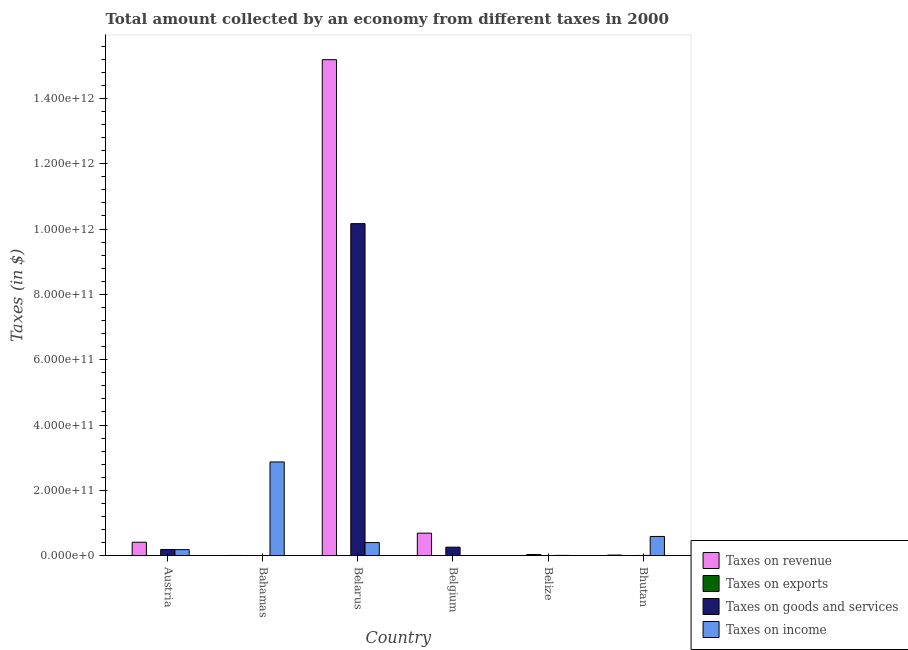Are the number of bars per tick equal to the number of legend labels?
Offer a very short reply. Yes. How many bars are there on the 5th tick from the right?
Your answer should be very brief. 4. What is the label of the 1st group of bars from the left?
Make the answer very short. Austria. In how many cases, is the number of bars for a given country not equal to the number of legend labels?
Your answer should be compact. 0. What is the amount collected as tax on revenue in Belarus?
Give a very brief answer. 1.52e+12. Across all countries, what is the maximum amount collected as tax on income?
Your answer should be compact. 2.87e+11. Across all countries, what is the minimum amount collected as tax on goods?
Offer a very short reply. 6.13e+07. In which country was the amount collected as tax on exports maximum?
Your answer should be very brief. Belize. What is the total amount collected as tax on exports in the graph?
Your answer should be very brief. 3.93e+09. What is the difference between the amount collected as tax on income in Bahamas and that in Belarus?
Provide a short and direct response. 2.47e+11. What is the difference between the amount collected as tax on goods in Bhutan and the amount collected as tax on income in Austria?
Offer a very short reply. -1.78e+1. What is the average amount collected as tax on revenue per country?
Ensure brevity in your answer.  2.72e+11. What is the difference between the amount collected as tax on exports and amount collected as tax on income in Austria?
Provide a succinct answer. -1.87e+1. What is the ratio of the amount collected as tax on income in Bahamas to that in Belgium?
Your answer should be very brief. 3760.61. What is the difference between the highest and the second highest amount collected as tax on exports?
Provide a succinct answer. 3.56e+09. What is the difference between the highest and the lowest amount collected as tax on income?
Provide a short and direct response. 2.87e+11. In how many countries, is the amount collected as tax on revenue greater than the average amount collected as tax on revenue taken over all countries?
Provide a short and direct response. 1. What does the 2nd bar from the left in Belarus represents?
Keep it short and to the point. Taxes on exports. What does the 3rd bar from the right in Belize represents?
Provide a succinct answer. Taxes on exports. How many bars are there?
Give a very brief answer. 24. Are all the bars in the graph horizontal?
Provide a succinct answer. No. How many countries are there in the graph?
Keep it short and to the point. 6. What is the difference between two consecutive major ticks on the Y-axis?
Your response must be concise. 2.00e+11. Are the values on the major ticks of Y-axis written in scientific E-notation?
Offer a terse response. Yes. Does the graph contain any zero values?
Your answer should be very brief. No. Does the graph contain grids?
Your answer should be compact. No. How many legend labels are there?
Make the answer very short. 4. What is the title of the graph?
Give a very brief answer. Total amount collected by an economy from different taxes in 2000. Does "Secondary schools" appear as one of the legend labels in the graph?
Keep it short and to the point. No. What is the label or title of the Y-axis?
Make the answer very short. Taxes (in $). What is the Taxes (in $) in Taxes on revenue in Austria?
Give a very brief answer. 4.13e+1. What is the Taxes (in $) in Taxes on exports in Austria?
Keep it short and to the point. 9.91e+04. What is the Taxes (in $) in Taxes on goods and services in Austria?
Offer a terse response. 1.91e+1. What is the Taxes (in $) of Taxes on income in Austria?
Offer a terse response. 1.87e+1. What is the Taxes (in $) in Taxes on revenue in Bahamas?
Keep it short and to the point. 8.62e+08. What is the Taxes (in $) in Taxes on exports in Bahamas?
Give a very brief answer. 1.15e+08. What is the Taxes (in $) of Taxes on goods and services in Bahamas?
Provide a succinct answer. 6.13e+07. What is the Taxes (in $) of Taxes on income in Bahamas?
Make the answer very short. 2.87e+11. What is the Taxes (in $) in Taxes on revenue in Belarus?
Offer a terse response. 1.52e+12. What is the Taxes (in $) of Taxes on exports in Belarus?
Keep it short and to the point. 1.49e+06. What is the Taxes (in $) in Taxes on goods and services in Belarus?
Give a very brief answer. 1.02e+12. What is the Taxes (in $) in Taxes on income in Belarus?
Your answer should be compact. 4.02e+1. What is the Taxes (in $) of Taxes on revenue in Belgium?
Offer a very short reply. 6.90e+1. What is the Taxes (in $) in Taxes on exports in Belgium?
Keep it short and to the point. 1.20e+07. What is the Taxes (in $) in Taxes on goods and services in Belgium?
Your answer should be very brief. 2.61e+1. What is the Taxes (in $) of Taxes on income in Belgium?
Offer a terse response. 7.63e+07. What is the Taxes (in $) of Taxes on revenue in Belize?
Your answer should be very brief. 2.97e+08. What is the Taxes (in $) of Taxes on exports in Belize?
Provide a succinct answer. 3.68e+09. What is the Taxes (in $) in Taxes on goods and services in Belize?
Offer a very short reply. 1.02e+08. What is the Taxes (in $) of Taxes on income in Belize?
Make the answer very short. 1.06e+09. What is the Taxes (in $) in Taxes on revenue in Bhutan?
Give a very brief answer. 1.98e+09. What is the Taxes (in $) in Taxes on exports in Bhutan?
Make the answer very short. 1.21e+08. What is the Taxes (in $) of Taxes on goods and services in Bhutan?
Give a very brief answer. 8.42e+08. What is the Taxes (in $) in Taxes on income in Bhutan?
Offer a very short reply. 5.90e+1. Across all countries, what is the maximum Taxes (in $) of Taxes on revenue?
Make the answer very short. 1.52e+12. Across all countries, what is the maximum Taxes (in $) in Taxes on exports?
Offer a very short reply. 3.68e+09. Across all countries, what is the maximum Taxes (in $) of Taxes on goods and services?
Keep it short and to the point. 1.02e+12. Across all countries, what is the maximum Taxes (in $) of Taxes on income?
Ensure brevity in your answer.  2.87e+11. Across all countries, what is the minimum Taxes (in $) of Taxes on revenue?
Keep it short and to the point. 2.97e+08. Across all countries, what is the minimum Taxes (in $) of Taxes on exports?
Offer a very short reply. 9.91e+04. Across all countries, what is the minimum Taxes (in $) of Taxes on goods and services?
Your answer should be compact. 6.13e+07. Across all countries, what is the minimum Taxes (in $) of Taxes on income?
Offer a terse response. 7.63e+07. What is the total Taxes (in $) of Taxes on revenue in the graph?
Give a very brief answer. 1.63e+12. What is the total Taxes (in $) in Taxes on exports in the graph?
Your answer should be very brief. 3.93e+09. What is the total Taxes (in $) of Taxes on goods and services in the graph?
Offer a very short reply. 1.06e+12. What is the total Taxes (in $) in Taxes on income in the graph?
Your response must be concise. 4.06e+11. What is the difference between the Taxes (in $) in Taxes on revenue in Austria and that in Bahamas?
Offer a very short reply. 4.04e+1. What is the difference between the Taxes (in $) of Taxes on exports in Austria and that in Bahamas?
Make the answer very short. -1.15e+08. What is the difference between the Taxes (in $) of Taxes on goods and services in Austria and that in Bahamas?
Your answer should be very brief. 1.90e+1. What is the difference between the Taxes (in $) in Taxes on income in Austria and that in Bahamas?
Give a very brief answer. -2.68e+11. What is the difference between the Taxes (in $) of Taxes on revenue in Austria and that in Belarus?
Ensure brevity in your answer.  -1.48e+12. What is the difference between the Taxes (in $) in Taxes on exports in Austria and that in Belarus?
Your response must be concise. -1.39e+06. What is the difference between the Taxes (in $) of Taxes on goods and services in Austria and that in Belarus?
Your response must be concise. -9.97e+11. What is the difference between the Taxes (in $) of Taxes on income in Austria and that in Belarus?
Provide a succinct answer. -2.15e+1. What is the difference between the Taxes (in $) of Taxes on revenue in Austria and that in Belgium?
Provide a succinct answer. -2.78e+1. What is the difference between the Taxes (in $) of Taxes on exports in Austria and that in Belgium?
Give a very brief answer. -1.19e+07. What is the difference between the Taxes (in $) of Taxes on goods and services in Austria and that in Belgium?
Ensure brevity in your answer.  -7.08e+09. What is the difference between the Taxes (in $) of Taxes on income in Austria and that in Belgium?
Offer a terse response. 1.86e+1. What is the difference between the Taxes (in $) of Taxes on revenue in Austria and that in Belize?
Ensure brevity in your answer.  4.10e+1. What is the difference between the Taxes (in $) of Taxes on exports in Austria and that in Belize?
Your response must be concise. -3.68e+09. What is the difference between the Taxes (in $) of Taxes on goods and services in Austria and that in Belize?
Offer a terse response. 1.90e+1. What is the difference between the Taxes (in $) in Taxes on income in Austria and that in Belize?
Your answer should be very brief. 1.76e+1. What is the difference between the Taxes (in $) of Taxes on revenue in Austria and that in Bhutan?
Give a very brief answer. 3.93e+1. What is the difference between the Taxes (in $) of Taxes on exports in Austria and that in Bhutan?
Make the answer very short. -1.21e+08. What is the difference between the Taxes (in $) in Taxes on goods and services in Austria and that in Bhutan?
Your answer should be compact. 1.82e+1. What is the difference between the Taxes (in $) of Taxes on income in Austria and that in Bhutan?
Ensure brevity in your answer.  -4.03e+1. What is the difference between the Taxes (in $) in Taxes on revenue in Bahamas and that in Belarus?
Your answer should be very brief. -1.52e+12. What is the difference between the Taxes (in $) in Taxes on exports in Bahamas and that in Belarus?
Your answer should be compact. 1.13e+08. What is the difference between the Taxes (in $) in Taxes on goods and services in Bahamas and that in Belarus?
Your response must be concise. -1.02e+12. What is the difference between the Taxes (in $) in Taxes on income in Bahamas and that in Belarus?
Provide a succinct answer. 2.47e+11. What is the difference between the Taxes (in $) in Taxes on revenue in Bahamas and that in Belgium?
Your answer should be compact. -6.82e+1. What is the difference between the Taxes (in $) in Taxes on exports in Bahamas and that in Belgium?
Provide a succinct answer. 1.03e+08. What is the difference between the Taxes (in $) in Taxes on goods and services in Bahamas and that in Belgium?
Keep it short and to the point. -2.61e+1. What is the difference between the Taxes (in $) of Taxes on income in Bahamas and that in Belgium?
Provide a short and direct response. 2.87e+11. What is the difference between the Taxes (in $) of Taxes on revenue in Bahamas and that in Belize?
Your answer should be compact. 5.66e+08. What is the difference between the Taxes (in $) in Taxes on exports in Bahamas and that in Belize?
Make the answer very short. -3.57e+09. What is the difference between the Taxes (in $) in Taxes on goods and services in Bahamas and that in Belize?
Offer a terse response. -4.05e+07. What is the difference between the Taxes (in $) in Taxes on income in Bahamas and that in Belize?
Provide a succinct answer. 2.86e+11. What is the difference between the Taxes (in $) of Taxes on revenue in Bahamas and that in Bhutan?
Give a very brief answer. -1.11e+09. What is the difference between the Taxes (in $) of Taxes on exports in Bahamas and that in Bhutan?
Offer a very short reply. -5.84e+06. What is the difference between the Taxes (in $) of Taxes on goods and services in Bahamas and that in Bhutan?
Ensure brevity in your answer.  -7.81e+08. What is the difference between the Taxes (in $) in Taxes on income in Bahamas and that in Bhutan?
Provide a succinct answer. 2.28e+11. What is the difference between the Taxes (in $) in Taxes on revenue in Belarus and that in Belgium?
Offer a terse response. 1.45e+12. What is the difference between the Taxes (in $) of Taxes on exports in Belarus and that in Belgium?
Offer a very short reply. -1.05e+07. What is the difference between the Taxes (in $) of Taxes on goods and services in Belarus and that in Belgium?
Ensure brevity in your answer.  9.90e+11. What is the difference between the Taxes (in $) of Taxes on income in Belarus and that in Belgium?
Ensure brevity in your answer.  4.01e+1. What is the difference between the Taxes (in $) of Taxes on revenue in Belarus and that in Belize?
Your answer should be very brief. 1.52e+12. What is the difference between the Taxes (in $) of Taxes on exports in Belarus and that in Belize?
Your answer should be compact. -3.68e+09. What is the difference between the Taxes (in $) of Taxes on goods and services in Belarus and that in Belize?
Keep it short and to the point. 1.02e+12. What is the difference between the Taxes (in $) in Taxes on income in Belarus and that in Belize?
Provide a succinct answer. 3.91e+1. What is the difference between the Taxes (in $) in Taxes on revenue in Belarus and that in Bhutan?
Ensure brevity in your answer.  1.52e+12. What is the difference between the Taxes (in $) of Taxes on exports in Belarus and that in Bhutan?
Your response must be concise. -1.19e+08. What is the difference between the Taxes (in $) of Taxes on goods and services in Belarus and that in Bhutan?
Keep it short and to the point. 1.02e+12. What is the difference between the Taxes (in $) in Taxes on income in Belarus and that in Bhutan?
Offer a terse response. -1.88e+1. What is the difference between the Taxes (in $) in Taxes on revenue in Belgium and that in Belize?
Provide a succinct answer. 6.87e+1. What is the difference between the Taxes (in $) of Taxes on exports in Belgium and that in Belize?
Your answer should be compact. -3.67e+09. What is the difference between the Taxes (in $) in Taxes on goods and services in Belgium and that in Belize?
Your answer should be compact. 2.60e+1. What is the difference between the Taxes (in $) in Taxes on income in Belgium and that in Belize?
Your answer should be compact. -9.80e+08. What is the difference between the Taxes (in $) in Taxes on revenue in Belgium and that in Bhutan?
Your response must be concise. 6.70e+1. What is the difference between the Taxes (in $) in Taxes on exports in Belgium and that in Bhutan?
Your answer should be compact. -1.09e+08. What is the difference between the Taxes (in $) of Taxes on goods and services in Belgium and that in Bhutan?
Ensure brevity in your answer.  2.53e+1. What is the difference between the Taxes (in $) of Taxes on income in Belgium and that in Bhutan?
Your answer should be compact. -5.89e+1. What is the difference between the Taxes (in $) of Taxes on revenue in Belize and that in Bhutan?
Provide a succinct answer. -1.68e+09. What is the difference between the Taxes (in $) of Taxes on exports in Belize and that in Bhutan?
Offer a very short reply. 3.56e+09. What is the difference between the Taxes (in $) of Taxes on goods and services in Belize and that in Bhutan?
Your answer should be compact. -7.41e+08. What is the difference between the Taxes (in $) of Taxes on income in Belize and that in Bhutan?
Make the answer very short. -5.79e+1. What is the difference between the Taxes (in $) of Taxes on revenue in Austria and the Taxes (in $) of Taxes on exports in Bahamas?
Your response must be concise. 4.11e+1. What is the difference between the Taxes (in $) of Taxes on revenue in Austria and the Taxes (in $) of Taxes on goods and services in Bahamas?
Provide a succinct answer. 4.12e+1. What is the difference between the Taxes (in $) of Taxes on revenue in Austria and the Taxes (in $) of Taxes on income in Bahamas?
Give a very brief answer. -2.46e+11. What is the difference between the Taxes (in $) in Taxes on exports in Austria and the Taxes (in $) in Taxes on goods and services in Bahamas?
Keep it short and to the point. -6.12e+07. What is the difference between the Taxes (in $) of Taxes on exports in Austria and the Taxes (in $) of Taxes on income in Bahamas?
Your answer should be compact. -2.87e+11. What is the difference between the Taxes (in $) in Taxes on goods and services in Austria and the Taxes (in $) in Taxes on income in Bahamas?
Your answer should be compact. -2.68e+11. What is the difference between the Taxes (in $) in Taxes on revenue in Austria and the Taxes (in $) in Taxes on exports in Belarus?
Keep it short and to the point. 4.13e+1. What is the difference between the Taxes (in $) in Taxes on revenue in Austria and the Taxes (in $) in Taxes on goods and services in Belarus?
Keep it short and to the point. -9.75e+11. What is the difference between the Taxes (in $) in Taxes on revenue in Austria and the Taxes (in $) in Taxes on income in Belarus?
Offer a very short reply. 1.07e+09. What is the difference between the Taxes (in $) of Taxes on exports in Austria and the Taxes (in $) of Taxes on goods and services in Belarus?
Provide a succinct answer. -1.02e+12. What is the difference between the Taxes (in $) of Taxes on exports in Austria and the Taxes (in $) of Taxes on income in Belarus?
Make the answer very short. -4.02e+1. What is the difference between the Taxes (in $) in Taxes on goods and services in Austria and the Taxes (in $) in Taxes on income in Belarus?
Your response must be concise. -2.11e+1. What is the difference between the Taxes (in $) of Taxes on revenue in Austria and the Taxes (in $) of Taxes on exports in Belgium?
Ensure brevity in your answer.  4.12e+1. What is the difference between the Taxes (in $) in Taxes on revenue in Austria and the Taxes (in $) in Taxes on goods and services in Belgium?
Keep it short and to the point. 1.51e+1. What is the difference between the Taxes (in $) in Taxes on revenue in Austria and the Taxes (in $) in Taxes on income in Belgium?
Keep it short and to the point. 4.12e+1. What is the difference between the Taxes (in $) of Taxes on exports in Austria and the Taxes (in $) of Taxes on goods and services in Belgium?
Your response must be concise. -2.61e+1. What is the difference between the Taxes (in $) of Taxes on exports in Austria and the Taxes (in $) of Taxes on income in Belgium?
Keep it short and to the point. -7.62e+07. What is the difference between the Taxes (in $) of Taxes on goods and services in Austria and the Taxes (in $) of Taxes on income in Belgium?
Your response must be concise. 1.90e+1. What is the difference between the Taxes (in $) of Taxes on revenue in Austria and the Taxes (in $) of Taxes on exports in Belize?
Offer a terse response. 3.76e+1. What is the difference between the Taxes (in $) of Taxes on revenue in Austria and the Taxes (in $) of Taxes on goods and services in Belize?
Keep it short and to the point. 4.12e+1. What is the difference between the Taxes (in $) in Taxes on revenue in Austria and the Taxes (in $) in Taxes on income in Belize?
Make the answer very short. 4.02e+1. What is the difference between the Taxes (in $) in Taxes on exports in Austria and the Taxes (in $) in Taxes on goods and services in Belize?
Make the answer very short. -1.02e+08. What is the difference between the Taxes (in $) in Taxes on exports in Austria and the Taxes (in $) in Taxes on income in Belize?
Provide a short and direct response. -1.06e+09. What is the difference between the Taxes (in $) in Taxes on goods and services in Austria and the Taxes (in $) in Taxes on income in Belize?
Ensure brevity in your answer.  1.80e+1. What is the difference between the Taxes (in $) of Taxes on revenue in Austria and the Taxes (in $) of Taxes on exports in Bhutan?
Your answer should be compact. 4.11e+1. What is the difference between the Taxes (in $) in Taxes on revenue in Austria and the Taxes (in $) in Taxes on goods and services in Bhutan?
Keep it short and to the point. 4.04e+1. What is the difference between the Taxes (in $) of Taxes on revenue in Austria and the Taxes (in $) of Taxes on income in Bhutan?
Your answer should be compact. -1.77e+1. What is the difference between the Taxes (in $) in Taxes on exports in Austria and the Taxes (in $) in Taxes on goods and services in Bhutan?
Make the answer very short. -8.42e+08. What is the difference between the Taxes (in $) of Taxes on exports in Austria and the Taxes (in $) of Taxes on income in Bhutan?
Offer a very short reply. -5.90e+1. What is the difference between the Taxes (in $) of Taxes on goods and services in Austria and the Taxes (in $) of Taxes on income in Bhutan?
Offer a very short reply. -3.99e+1. What is the difference between the Taxes (in $) in Taxes on revenue in Bahamas and the Taxes (in $) in Taxes on exports in Belarus?
Give a very brief answer. 8.61e+08. What is the difference between the Taxes (in $) of Taxes on revenue in Bahamas and the Taxes (in $) of Taxes on goods and services in Belarus?
Provide a succinct answer. -1.02e+12. What is the difference between the Taxes (in $) in Taxes on revenue in Bahamas and the Taxes (in $) in Taxes on income in Belarus?
Offer a terse response. -3.93e+1. What is the difference between the Taxes (in $) in Taxes on exports in Bahamas and the Taxes (in $) in Taxes on goods and services in Belarus?
Your answer should be very brief. -1.02e+12. What is the difference between the Taxes (in $) of Taxes on exports in Bahamas and the Taxes (in $) of Taxes on income in Belarus?
Your response must be concise. -4.01e+1. What is the difference between the Taxes (in $) of Taxes on goods and services in Bahamas and the Taxes (in $) of Taxes on income in Belarus?
Your response must be concise. -4.01e+1. What is the difference between the Taxes (in $) in Taxes on revenue in Bahamas and the Taxes (in $) in Taxes on exports in Belgium?
Offer a terse response. 8.50e+08. What is the difference between the Taxes (in $) of Taxes on revenue in Bahamas and the Taxes (in $) of Taxes on goods and services in Belgium?
Your answer should be very brief. -2.53e+1. What is the difference between the Taxes (in $) in Taxes on revenue in Bahamas and the Taxes (in $) in Taxes on income in Belgium?
Your answer should be compact. 7.86e+08. What is the difference between the Taxes (in $) of Taxes on exports in Bahamas and the Taxes (in $) of Taxes on goods and services in Belgium?
Ensure brevity in your answer.  -2.60e+1. What is the difference between the Taxes (in $) in Taxes on exports in Bahamas and the Taxes (in $) in Taxes on income in Belgium?
Ensure brevity in your answer.  3.86e+07. What is the difference between the Taxes (in $) in Taxes on goods and services in Bahamas and the Taxes (in $) in Taxes on income in Belgium?
Offer a terse response. -1.50e+07. What is the difference between the Taxes (in $) of Taxes on revenue in Bahamas and the Taxes (in $) of Taxes on exports in Belize?
Make the answer very short. -2.82e+09. What is the difference between the Taxes (in $) of Taxes on revenue in Bahamas and the Taxes (in $) of Taxes on goods and services in Belize?
Give a very brief answer. 7.61e+08. What is the difference between the Taxes (in $) in Taxes on revenue in Bahamas and the Taxes (in $) in Taxes on income in Belize?
Give a very brief answer. -1.94e+08. What is the difference between the Taxes (in $) in Taxes on exports in Bahamas and the Taxes (in $) in Taxes on goods and services in Belize?
Offer a terse response. 1.30e+07. What is the difference between the Taxes (in $) of Taxes on exports in Bahamas and the Taxes (in $) of Taxes on income in Belize?
Ensure brevity in your answer.  -9.42e+08. What is the difference between the Taxes (in $) of Taxes on goods and services in Bahamas and the Taxes (in $) of Taxes on income in Belize?
Provide a succinct answer. -9.95e+08. What is the difference between the Taxes (in $) of Taxes on revenue in Bahamas and the Taxes (in $) of Taxes on exports in Bhutan?
Ensure brevity in your answer.  7.42e+08. What is the difference between the Taxes (in $) in Taxes on revenue in Bahamas and the Taxes (in $) in Taxes on goods and services in Bhutan?
Provide a short and direct response. 2.00e+07. What is the difference between the Taxes (in $) of Taxes on revenue in Bahamas and the Taxes (in $) of Taxes on income in Bhutan?
Provide a succinct answer. -5.81e+1. What is the difference between the Taxes (in $) of Taxes on exports in Bahamas and the Taxes (in $) of Taxes on goods and services in Bhutan?
Offer a terse response. -7.28e+08. What is the difference between the Taxes (in $) in Taxes on exports in Bahamas and the Taxes (in $) in Taxes on income in Bhutan?
Provide a succinct answer. -5.89e+1. What is the difference between the Taxes (in $) in Taxes on goods and services in Bahamas and the Taxes (in $) in Taxes on income in Bhutan?
Your response must be concise. -5.89e+1. What is the difference between the Taxes (in $) of Taxes on revenue in Belarus and the Taxes (in $) of Taxes on exports in Belgium?
Provide a short and direct response. 1.52e+12. What is the difference between the Taxes (in $) in Taxes on revenue in Belarus and the Taxes (in $) in Taxes on goods and services in Belgium?
Your answer should be very brief. 1.49e+12. What is the difference between the Taxes (in $) of Taxes on revenue in Belarus and the Taxes (in $) of Taxes on income in Belgium?
Make the answer very short. 1.52e+12. What is the difference between the Taxes (in $) of Taxes on exports in Belarus and the Taxes (in $) of Taxes on goods and services in Belgium?
Make the answer very short. -2.61e+1. What is the difference between the Taxes (in $) in Taxes on exports in Belarus and the Taxes (in $) in Taxes on income in Belgium?
Make the answer very short. -7.48e+07. What is the difference between the Taxes (in $) of Taxes on goods and services in Belarus and the Taxes (in $) of Taxes on income in Belgium?
Your response must be concise. 1.02e+12. What is the difference between the Taxes (in $) of Taxes on revenue in Belarus and the Taxes (in $) of Taxes on exports in Belize?
Make the answer very short. 1.51e+12. What is the difference between the Taxes (in $) of Taxes on revenue in Belarus and the Taxes (in $) of Taxes on goods and services in Belize?
Your answer should be very brief. 1.52e+12. What is the difference between the Taxes (in $) in Taxes on revenue in Belarus and the Taxes (in $) in Taxes on income in Belize?
Ensure brevity in your answer.  1.52e+12. What is the difference between the Taxes (in $) of Taxes on exports in Belarus and the Taxes (in $) of Taxes on goods and services in Belize?
Provide a short and direct response. -1.00e+08. What is the difference between the Taxes (in $) in Taxes on exports in Belarus and the Taxes (in $) in Taxes on income in Belize?
Make the answer very short. -1.06e+09. What is the difference between the Taxes (in $) in Taxes on goods and services in Belarus and the Taxes (in $) in Taxes on income in Belize?
Ensure brevity in your answer.  1.02e+12. What is the difference between the Taxes (in $) in Taxes on revenue in Belarus and the Taxes (in $) in Taxes on exports in Bhutan?
Give a very brief answer. 1.52e+12. What is the difference between the Taxes (in $) in Taxes on revenue in Belarus and the Taxes (in $) in Taxes on goods and services in Bhutan?
Give a very brief answer. 1.52e+12. What is the difference between the Taxes (in $) of Taxes on revenue in Belarus and the Taxes (in $) of Taxes on income in Bhutan?
Offer a very short reply. 1.46e+12. What is the difference between the Taxes (in $) in Taxes on exports in Belarus and the Taxes (in $) in Taxes on goods and services in Bhutan?
Your response must be concise. -8.41e+08. What is the difference between the Taxes (in $) of Taxes on exports in Belarus and the Taxes (in $) of Taxes on income in Bhutan?
Provide a short and direct response. -5.90e+1. What is the difference between the Taxes (in $) of Taxes on goods and services in Belarus and the Taxes (in $) of Taxes on income in Bhutan?
Give a very brief answer. 9.58e+11. What is the difference between the Taxes (in $) of Taxes on revenue in Belgium and the Taxes (in $) of Taxes on exports in Belize?
Your response must be concise. 6.53e+1. What is the difference between the Taxes (in $) of Taxes on revenue in Belgium and the Taxes (in $) of Taxes on goods and services in Belize?
Your answer should be compact. 6.89e+1. What is the difference between the Taxes (in $) in Taxes on revenue in Belgium and the Taxes (in $) in Taxes on income in Belize?
Your answer should be compact. 6.80e+1. What is the difference between the Taxes (in $) of Taxes on exports in Belgium and the Taxes (in $) of Taxes on goods and services in Belize?
Keep it short and to the point. -8.98e+07. What is the difference between the Taxes (in $) in Taxes on exports in Belgium and the Taxes (in $) in Taxes on income in Belize?
Your answer should be very brief. -1.04e+09. What is the difference between the Taxes (in $) in Taxes on goods and services in Belgium and the Taxes (in $) in Taxes on income in Belize?
Give a very brief answer. 2.51e+1. What is the difference between the Taxes (in $) in Taxes on revenue in Belgium and the Taxes (in $) in Taxes on exports in Bhutan?
Your response must be concise. 6.89e+1. What is the difference between the Taxes (in $) of Taxes on revenue in Belgium and the Taxes (in $) of Taxes on goods and services in Bhutan?
Your answer should be compact. 6.82e+1. What is the difference between the Taxes (in $) of Taxes on revenue in Belgium and the Taxes (in $) of Taxes on income in Bhutan?
Provide a succinct answer. 1.00e+1. What is the difference between the Taxes (in $) of Taxes on exports in Belgium and the Taxes (in $) of Taxes on goods and services in Bhutan?
Provide a short and direct response. -8.30e+08. What is the difference between the Taxes (in $) of Taxes on exports in Belgium and the Taxes (in $) of Taxes on income in Bhutan?
Provide a succinct answer. -5.90e+1. What is the difference between the Taxes (in $) of Taxes on goods and services in Belgium and the Taxes (in $) of Taxes on income in Bhutan?
Ensure brevity in your answer.  -3.28e+1. What is the difference between the Taxes (in $) in Taxes on revenue in Belize and the Taxes (in $) in Taxes on exports in Bhutan?
Keep it short and to the point. 1.76e+08. What is the difference between the Taxes (in $) in Taxes on revenue in Belize and the Taxes (in $) in Taxes on goods and services in Bhutan?
Give a very brief answer. -5.46e+08. What is the difference between the Taxes (in $) of Taxes on revenue in Belize and the Taxes (in $) of Taxes on income in Bhutan?
Keep it short and to the point. -5.87e+1. What is the difference between the Taxes (in $) in Taxes on exports in Belize and the Taxes (in $) in Taxes on goods and services in Bhutan?
Keep it short and to the point. 2.84e+09. What is the difference between the Taxes (in $) of Taxes on exports in Belize and the Taxes (in $) of Taxes on income in Bhutan?
Make the answer very short. -5.53e+1. What is the difference between the Taxes (in $) of Taxes on goods and services in Belize and the Taxes (in $) of Taxes on income in Bhutan?
Offer a very short reply. -5.89e+1. What is the average Taxes (in $) in Taxes on revenue per country?
Make the answer very short. 2.72e+11. What is the average Taxes (in $) of Taxes on exports per country?
Keep it short and to the point. 6.55e+08. What is the average Taxes (in $) in Taxes on goods and services per country?
Your answer should be very brief. 1.77e+11. What is the average Taxes (in $) in Taxes on income per country?
Provide a short and direct response. 6.77e+1. What is the difference between the Taxes (in $) of Taxes on revenue and Taxes (in $) of Taxes on exports in Austria?
Provide a succinct answer. 4.13e+1. What is the difference between the Taxes (in $) in Taxes on revenue and Taxes (in $) in Taxes on goods and services in Austria?
Provide a succinct answer. 2.22e+1. What is the difference between the Taxes (in $) in Taxes on revenue and Taxes (in $) in Taxes on income in Austria?
Provide a short and direct response. 2.26e+1. What is the difference between the Taxes (in $) of Taxes on exports and Taxes (in $) of Taxes on goods and services in Austria?
Keep it short and to the point. -1.91e+1. What is the difference between the Taxes (in $) in Taxes on exports and Taxes (in $) in Taxes on income in Austria?
Provide a short and direct response. -1.87e+1. What is the difference between the Taxes (in $) in Taxes on goods and services and Taxes (in $) in Taxes on income in Austria?
Ensure brevity in your answer.  4.18e+08. What is the difference between the Taxes (in $) in Taxes on revenue and Taxes (in $) in Taxes on exports in Bahamas?
Give a very brief answer. 7.48e+08. What is the difference between the Taxes (in $) in Taxes on revenue and Taxes (in $) in Taxes on goods and services in Bahamas?
Offer a very short reply. 8.01e+08. What is the difference between the Taxes (in $) of Taxes on revenue and Taxes (in $) of Taxes on income in Bahamas?
Your answer should be very brief. -2.86e+11. What is the difference between the Taxes (in $) in Taxes on exports and Taxes (in $) in Taxes on goods and services in Bahamas?
Offer a very short reply. 5.36e+07. What is the difference between the Taxes (in $) in Taxes on exports and Taxes (in $) in Taxes on income in Bahamas?
Your answer should be very brief. -2.87e+11. What is the difference between the Taxes (in $) of Taxes on goods and services and Taxes (in $) of Taxes on income in Bahamas?
Offer a terse response. -2.87e+11. What is the difference between the Taxes (in $) of Taxes on revenue and Taxes (in $) of Taxes on exports in Belarus?
Offer a very short reply. 1.52e+12. What is the difference between the Taxes (in $) in Taxes on revenue and Taxes (in $) in Taxes on goods and services in Belarus?
Keep it short and to the point. 5.02e+11. What is the difference between the Taxes (in $) of Taxes on revenue and Taxes (in $) of Taxes on income in Belarus?
Offer a terse response. 1.48e+12. What is the difference between the Taxes (in $) of Taxes on exports and Taxes (in $) of Taxes on goods and services in Belarus?
Give a very brief answer. -1.02e+12. What is the difference between the Taxes (in $) of Taxes on exports and Taxes (in $) of Taxes on income in Belarus?
Offer a very short reply. -4.02e+1. What is the difference between the Taxes (in $) in Taxes on goods and services and Taxes (in $) in Taxes on income in Belarus?
Your answer should be very brief. 9.76e+11. What is the difference between the Taxes (in $) in Taxes on revenue and Taxes (in $) in Taxes on exports in Belgium?
Keep it short and to the point. 6.90e+1. What is the difference between the Taxes (in $) in Taxes on revenue and Taxes (in $) in Taxes on goods and services in Belgium?
Your answer should be compact. 4.29e+1. What is the difference between the Taxes (in $) in Taxes on revenue and Taxes (in $) in Taxes on income in Belgium?
Provide a short and direct response. 6.89e+1. What is the difference between the Taxes (in $) in Taxes on exports and Taxes (in $) in Taxes on goods and services in Belgium?
Make the answer very short. -2.61e+1. What is the difference between the Taxes (in $) of Taxes on exports and Taxes (in $) of Taxes on income in Belgium?
Give a very brief answer. -6.43e+07. What is the difference between the Taxes (in $) of Taxes on goods and services and Taxes (in $) of Taxes on income in Belgium?
Provide a short and direct response. 2.61e+1. What is the difference between the Taxes (in $) of Taxes on revenue and Taxes (in $) of Taxes on exports in Belize?
Your response must be concise. -3.38e+09. What is the difference between the Taxes (in $) of Taxes on revenue and Taxes (in $) of Taxes on goods and services in Belize?
Keep it short and to the point. 1.95e+08. What is the difference between the Taxes (in $) of Taxes on revenue and Taxes (in $) of Taxes on income in Belize?
Give a very brief answer. -7.60e+08. What is the difference between the Taxes (in $) of Taxes on exports and Taxes (in $) of Taxes on goods and services in Belize?
Your answer should be compact. 3.58e+09. What is the difference between the Taxes (in $) in Taxes on exports and Taxes (in $) in Taxes on income in Belize?
Give a very brief answer. 2.62e+09. What is the difference between the Taxes (in $) of Taxes on goods and services and Taxes (in $) of Taxes on income in Belize?
Ensure brevity in your answer.  -9.55e+08. What is the difference between the Taxes (in $) of Taxes on revenue and Taxes (in $) of Taxes on exports in Bhutan?
Make the answer very short. 1.86e+09. What is the difference between the Taxes (in $) in Taxes on revenue and Taxes (in $) in Taxes on goods and services in Bhutan?
Give a very brief answer. 1.13e+09. What is the difference between the Taxes (in $) in Taxes on revenue and Taxes (in $) in Taxes on income in Bhutan?
Your answer should be very brief. -5.70e+1. What is the difference between the Taxes (in $) in Taxes on exports and Taxes (in $) in Taxes on goods and services in Bhutan?
Offer a very short reply. -7.22e+08. What is the difference between the Taxes (in $) of Taxes on exports and Taxes (in $) of Taxes on income in Bhutan?
Ensure brevity in your answer.  -5.88e+1. What is the difference between the Taxes (in $) in Taxes on goods and services and Taxes (in $) in Taxes on income in Bhutan?
Ensure brevity in your answer.  -5.81e+1. What is the ratio of the Taxes (in $) of Taxes on revenue in Austria to that in Bahamas?
Provide a succinct answer. 47.84. What is the ratio of the Taxes (in $) of Taxes on exports in Austria to that in Bahamas?
Give a very brief answer. 0. What is the ratio of the Taxes (in $) in Taxes on goods and services in Austria to that in Bahamas?
Ensure brevity in your answer.  311.11. What is the ratio of the Taxes (in $) in Taxes on income in Austria to that in Bahamas?
Your answer should be very brief. 0.07. What is the ratio of the Taxes (in $) of Taxes on revenue in Austria to that in Belarus?
Make the answer very short. 0.03. What is the ratio of the Taxes (in $) in Taxes on exports in Austria to that in Belarus?
Give a very brief answer. 0.07. What is the ratio of the Taxes (in $) of Taxes on goods and services in Austria to that in Belarus?
Keep it short and to the point. 0.02. What is the ratio of the Taxes (in $) of Taxes on income in Austria to that in Belarus?
Provide a succinct answer. 0.46. What is the ratio of the Taxes (in $) of Taxes on revenue in Austria to that in Belgium?
Offer a very short reply. 0.6. What is the ratio of the Taxes (in $) of Taxes on exports in Austria to that in Belgium?
Give a very brief answer. 0.01. What is the ratio of the Taxes (in $) in Taxes on goods and services in Austria to that in Belgium?
Keep it short and to the point. 0.73. What is the ratio of the Taxes (in $) of Taxes on income in Austria to that in Belgium?
Offer a terse response. 244.41. What is the ratio of the Taxes (in $) in Taxes on revenue in Austria to that in Belize?
Give a very brief answer. 139.08. What is the ratio of the Taxes (in $) in Taxes on goods and services in Austria to that in Belize?
Your response must be concise. 187.25. What is the ratio of the Taxes (in $) in Taxes on income in Austria to that in Belize?
Your answer should be compact. 17.65. What is the ratio of the Taxes (in $) in Taxes on revenue in Austria to that in Bhutan?
Offer a very short reply. 20.87. What is the ratio of the Taxes (in $) of Taxes on exports in Austria to that in Bhutan?
Offer a terse response. 0. What is the ratio of the Taxes (in $) of Taxes on goods and services in Austria to that in Bhutan?
Your response must be concise. 22.64. What is the ratio of the Taxes (in $) in Taxes on income in Austria to that in Bhutan?
Give a very brief answer. 0.32. What is the ratio of the Taxes (in $) of Taxes on revenue in Bahamas to that in Belarus?
Provide a short and direct response. 0. What is the ratio of the Taxes (in $) of Taxes on exports in Bahamas to that in Belarus?
Keep it short and to the point. 77.1. What is the ratio of the Taxes (in $) in Taxes on income in Bahamas to that in Belarus?
Provide a succinct answer. 7.14. What is the ratio of the Taxes (in $) of Taxes on revenue in Bahamas to that in Belgium?
Offer a terse response. 0.01. What is the ratio of the Taxes (in $) in Taxes on exports in Bahamas to that in Belgium?
Offer a terse response. 9.57. What is the ratio of the Taxes (in $) of Taxes on goods and services in Bahamas to that in Belgium?
Offer a very short reply. 0. What is the ratio of the Taxes (in $) in Taxes on income in Bahamas to that in Belgium?
Keep it short and to the point. 3760.61. What is the ratio of the Taxes (in $) of Taxes on revenue in Bahamas to that in Belize?
Your answer should be compact. 2.91. What is the ratio of the Taxes (in $) in Taxes on exports in Bahamas to that in Belize?
Offer a terse response. 0.03. What is the ratio of the Taxes (in $) of Taxes on goods and services in Bahamas to that in Belize?
Ensure brevity in your answer.  0.6. What is the ratio of the Taxes (in $) in Taxes on income in Bahamas to that in Belize?
Give a very brief answer. 271.61. What is the ratio of the Taxes (in $) in Taxes on revenue in Bahamas to that in Bhutan?
Offer a very short reply. 0.44. What is the ratio of the Taxes (in $) of Taxes on exports in Bahamas to that in Bhutan?
Make the answer very short. 0.95. What is the ratio of the Taxes (in $) of Taxes on goods and services in Bahamas to that in Bhutan?
Give a very brief answer. 0.07. What is the ratio of the Taxes (in $) in Taxes on income in Bahamas to that in Bhutan?
Provide a short and direct response. 4.87. What is the ratio of the Taxes (in $) of Taxes on revenue in Belarus to that in Belgium?
Your answer should be compact. 22. What is the ratio of the Taxes (in $) of Taxes on exports in Belarus to that in Belgium?
Provide a succinct answer. 0.12. What is the ratio of the Taxes (in $) in Taxes on goods and services in Belarus to that in Belgium?
Provide a short and direct response. 38.88. What is the ratio of the Taxes (in $) in Taxes on income in Belarus to that in Belgium?
Make the answer very short. 526.67. What is the ratio of the Taxes (in $) in Taxes on revenue in Belarus to that in Belize?
Offer a very short reply. 5118.26. What is the ratio of the Taxes (in $) of Taxes on goods and services in Belarus to that in Belize?
Make the answer very short. 9981.05. What is the ratio of the Taxes (in $) of Taxes on income in Belarus to that in Belize?
Give a very brief answer. 38.04. What is the ratio of the Taxes (in $) of Taxes on revenue in Belarus to that in Bhutan?
Your answer should be compact. 768.03. What is the ratio of the Taxes (in $) in Taxes on exports in Belarus to that in Bhutan?
Offer a very short reply. 0.01. What is the ratio of the Taxes (in $) in Taxes on goods and services in Belarus to that in Bhutan?
Your answer should be very brief. 1206.6. What is the ratio of the Taxes (in $) of Taxes on income in Belarus to that in Bhutan?
Your answer should be very brief. 0.68. What is the ratio of the Taxes (in $) of Taxes on revenue in Belgium to that in Belize?
Offer a very short reply. 232.62. What is the ratio of the Taxes (in $) in Taxes on exports in Belgium to that in Belize?
Your answer should be compact. 0. What is the ratio of the Taxes (in $) in Taxes on goods and services in Belgium to that in Belize?
Offer a terse response. 256.73. What is the ratio of the Taxes (in $) in Taxes on income in Belgium to that in Belize?
Give a very brief answer. 0.07. What is the ratio of the Taxes (in $) of Taxes on revenue in Belgium to that in Bhutan?
Your response must be concise. 34.91. What is the ratio of the Taxes (in $) in Taxes on exports in Belgium to that in Bhutan?
Give a very brief answer. 0.1. What is the ratio of the Taxes (in $) in Taxes on goods and services in Belgium to that in Bhutan?
Provide a short and direct response. 31.04. What is the ratio of the Taxes (in $) of Taxes on income in Belgium to that in Bhutan?
Your response must be concise. 0. What is the ratio of the Taxes (in $) in Taxes on revenue in Belize to that in Bhutan?
Provide a short and direct response. 0.15. What is the ratio of the Taxes (in $) in Taxes on exports in Belize to that in Bhutan?
Give a very brief answer. 30.48. What is the ratio of the Taxes (in $) in Taxes on goods and services in Belize to that in Bhutan?
Offer a terse response. 0.12. What is the ratio of the Taxes (in $) of Taxes on income in Belize to that in Bhutan?
Give a very brief answer. 0.02. What is the difference between the highest and the second highest Taxes (in $) in Taxes on revenue?
Offer a very short reply. 1.45e+12. What is the difference between the highest and the second highest Taxes (in $) of Taxes on exports?
Your answer should be very brief. 3.56e+09. What is the difference between the highest and the second highest Taxes (in $) in Taxes on goods and services?
Your answer should be compact. 9.90e+11. What is the difference between the highest and the second highest Taxes (in $) of Taxes on income?
Ensure brevity in your answer.  2.28e+11. What is the difference between the highest and the lowest Taxes (in $) of Taxes on revenue?
Keep it short and to the point. 1.52e+12. What is the difference between the highest and the lowest Taxes (in $) in Taxes on exports?
Offer a very short reply. 3.68e+09. What is the difference between the highest and the lowest Taxes (in $) of Taxes on goods and services?
Provide a short and direct response. 1.02e+12. What is the difference between the highest and the lowest Taxes (in $) in Taxes on income?
Make the answer very short. 2.87e+11. 